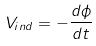Convert formula to latex. <formula><loc_0><loc_0><loc_500><loc_500>V _ { i n d } = - \frac { d \phi } { d t }</formula> 